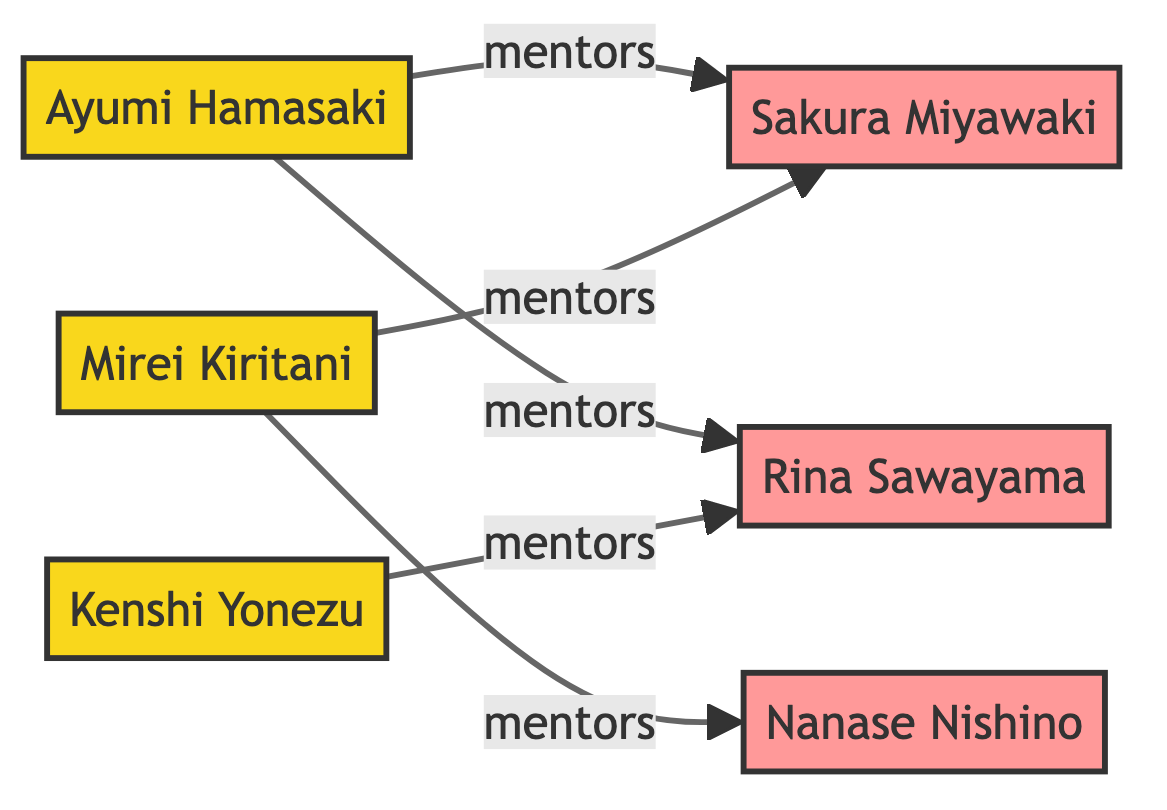What is the total number of nodes in the diagram? The nodes listed in the data are Ayumi Hamasaki, Kenshi Yonezu, Sakura Miyawaki, Rina Sawayama, Mirei Kiritani, and Nanase Nishino, totaling six.
Answer: 6 Who mentors Rina Sawayama? According to the edges, Ayumi Hamasaki and Kenshi Yonezu have a mentoring relationship with Rina Sawayama.
Answer: Ayumi Hamasaki, Kenshi Yonezu How many idols are represented in the diagram? The nodes for idols are Sakura Miyawaki, Rina Sawayama, and Nanase Nishino. Counting these gives a total of three idols.
Answer: 3 Which mentor has the most connections to idols? By reviewing the edges, Ayumi Hamasaki has connections with both Sakura Miyawaki and Rina Sawayama, while Mirei Kiritani also connects to Sakura Miyawaki and Nanase Nishino. Since both have two connections, they are equally the most connected.
Answer: Ayumi Hamasaki, Mirei Kiritani What type of relationships connect mentors to idols in the diagram? The relationship between mentors and idols is defined as "mentors," as labeled on the directed edges in the diagram.
Answer: mentors How many edges are there in total? The edges listed include five distinct mentoring relationships, which are counted for the total.
Answer: 5 Which idol is mentored by both Ayumi Hamasaki and Mirei Kiritani? Sakura Miyawaki is the idol mentioned in the edges from both Ayumi Hamasaki and Mirei Kiritani, indicating her connection to both mentors.
Answer: Sakura Miyawaki How many mentors are there in the diagram? The nodes denoting mentors are Ayumi Hamasaki, Kenshi Yonezu, and Mirei Kiritani, amounting to three mentors in total.
Answer: 3 Who is the only idol mentored by Mirei Kiritani? The node indicates that Nanase Nishino is the idol who is only mentored by Mirei Kiritani, evidenced by the specific edge connecting them.
Answer: Nanase Nishino 